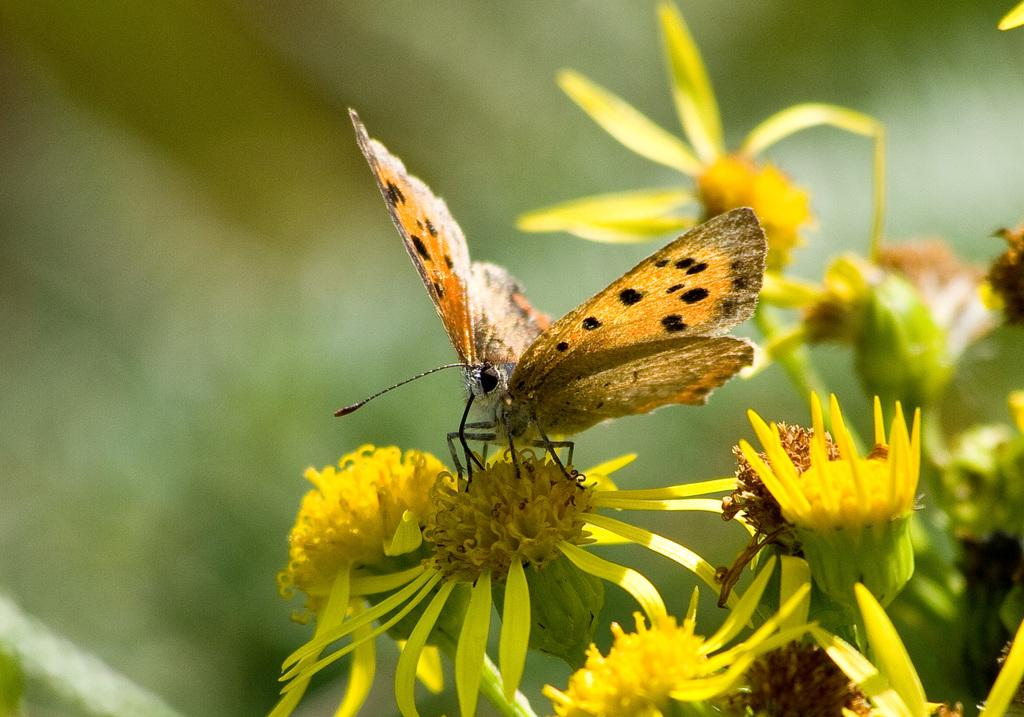What is the main subject of the image? There is a butterfly in the image. What is the butterfly resting on? The butterfly is on yellow color flowers. Can you describe the flowers in the image? There are yellow color flowers in the image. What type of soap is being used to clean the butterfly's wing in the image? There is no soap or cleaning activity involving the butterfly's wing in the image. 